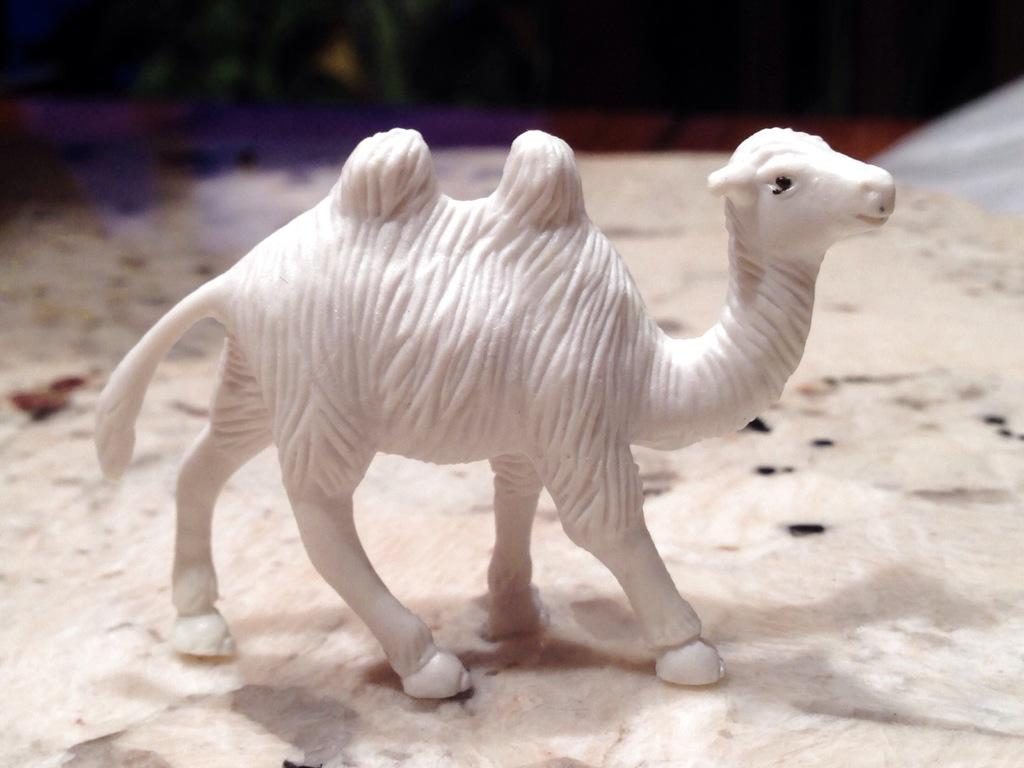What type of object is present on the white surface in the image? There is a toy of an animal in the image. What color is the toy? The toy is white in color. What is the color of the surface the toy is placed on? The surface is white. Can you describe the background of the image? The background of the image is blurred. What type of plant is growing in the background of the image? There is no plant visible in the image, as the background is blurred. 